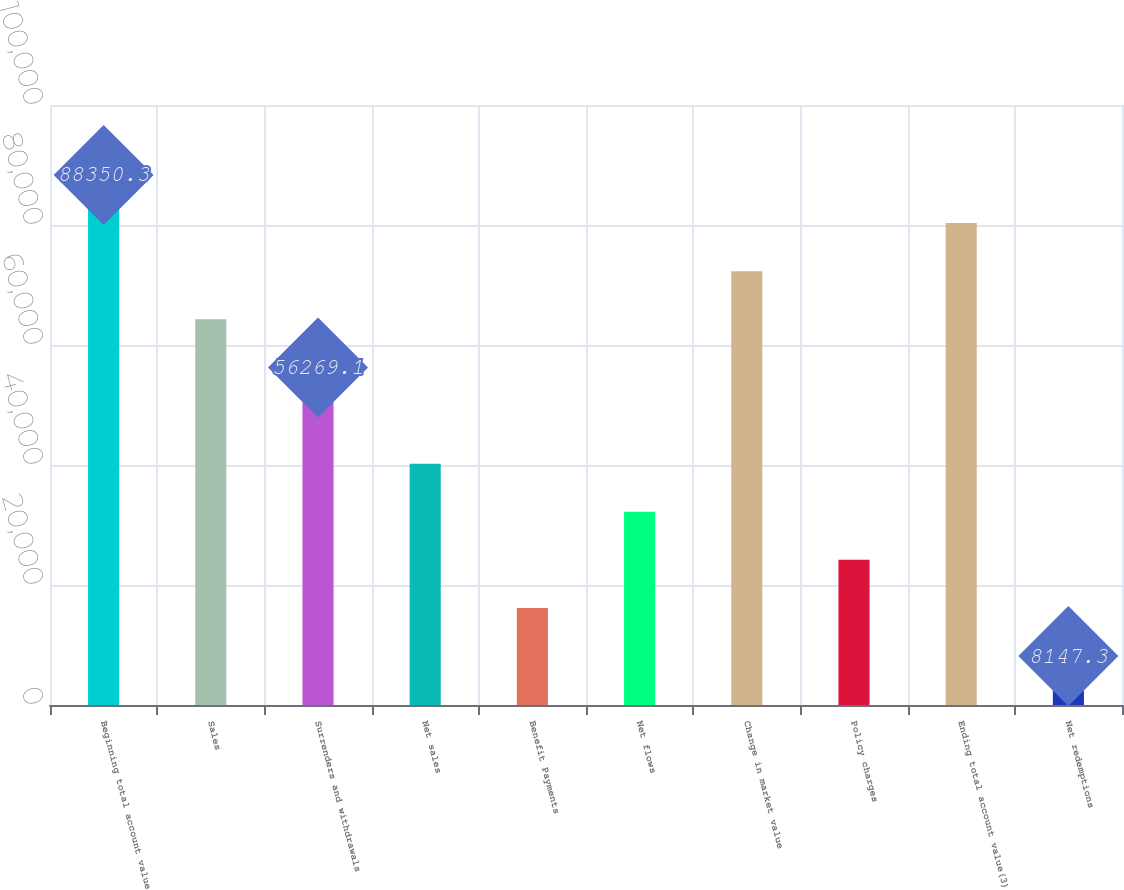Convert chart to OTSL. <chart><loc_0><loc_0><loc_500><loc_500><bar_chart><fcel>Beginning total account value<fcel>Sales<fcel>Surrenders and withdrawals<fcel>Net sales<fcel>Benefit Payments<fcel>Net flows<fcel>Change in market value<fcel>Policy charges<fcel>Ending total account value(3)<fcel>Net redemptions<nl><fcel>88350.3<fcel>64289.4<fcel>56269.1<fcel>40228.5<fcel>16167.6<fcel>32208.2<fcel>72309.7<fcel>24187.9<fcel>80330<fcel>8147.3<nl></chart> 